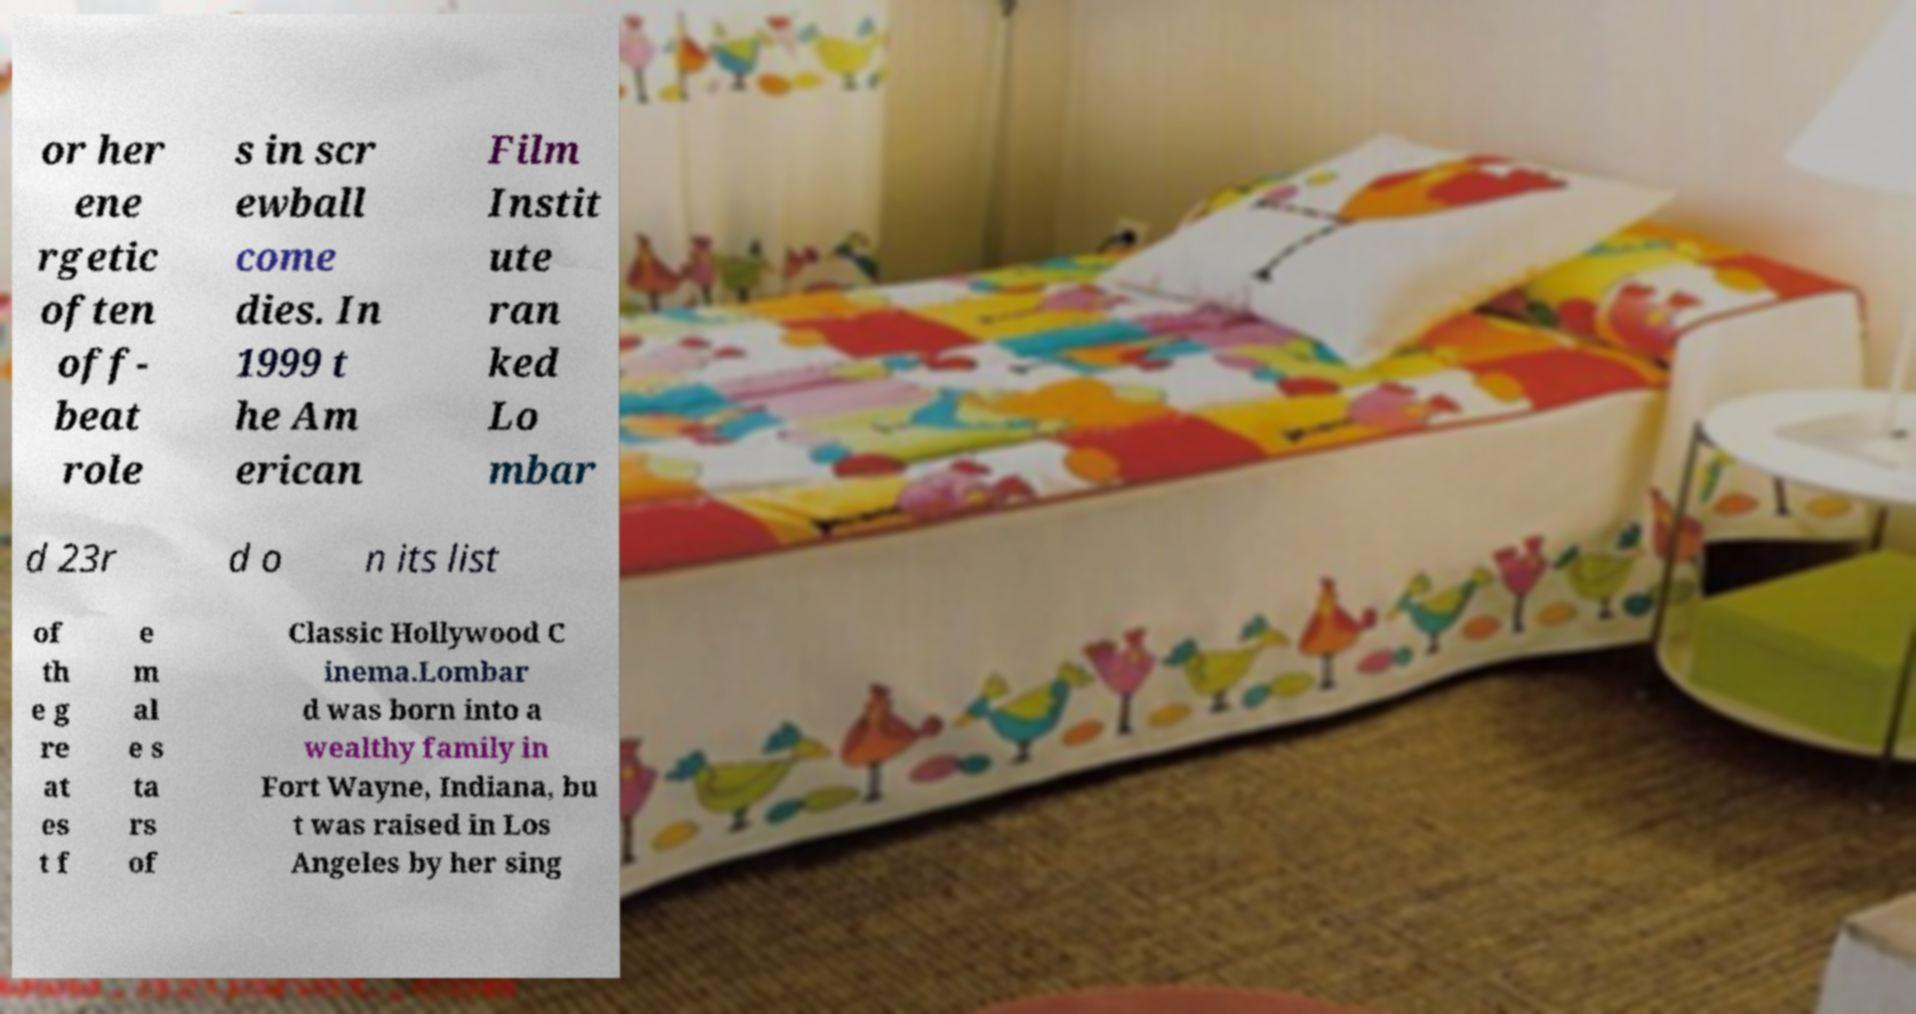For documentation purposes, I need the text within this image transcribed. Could you provide that? or her ene rgetic often off- beat role s in scr ewball come dies. In 1999 t he Am erican Film Instit ute ran ked Lo mbar d 23r d o n its list of th e g re at es t f e m al e s ta rs of Classic Hollywood C inema.Lombar d was born into a wealthy family in Fort Wayne, Indiana, bu t was raised in Los Angeles by her sing 